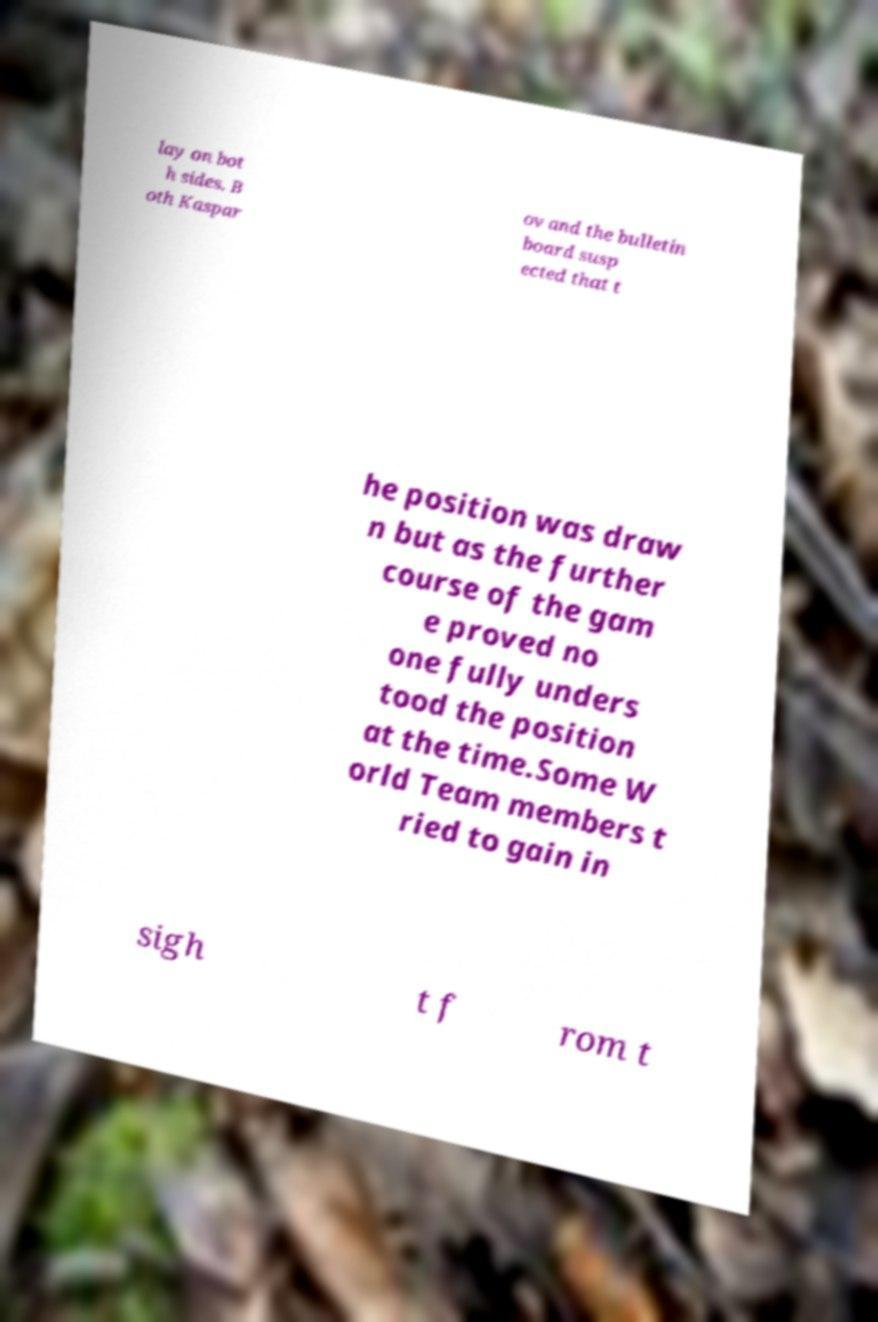Can you read and provide the text displayed in the image?This photo seems to have some interesting text. Can you extract and type it out for me? lay on bot h sides. B oth Kaspar ov and the bulletin board susp ected that t he position was draw n but as the further course of the gam e proved no one fully unders tood the position at the time.Some W orld Team members t ried to gain in sigh t f rom t 